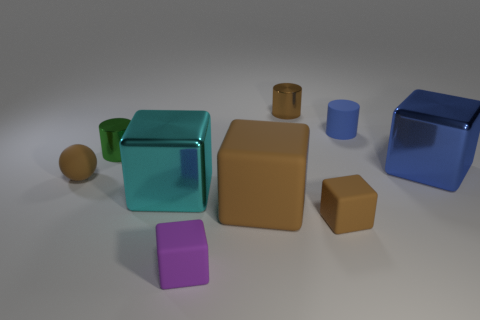Is the color of the sphere the same as the large matte block?
Make the answer very short. Yes. There is a thing that is both in front of the blue metallic block and right of the big brown matte thing; what is its size?
Provide a succinct answer. Small. The blue matte thing has what shape?
Give a very brief answer. Cylinder. How many objects are tiny gray cylinders or metal cylinders behind the tiny green metallic cylinder?
Ensure brevity in your answer.  1. Does the large shiny cube that is right of the purple block have the same color as the matte cylinder?
Ensure brevity in your answer.  Yes. There is a tiny cylinder that is both on the right side of the large brown object and in front of the tiny brown cylinder; what color is it?
Make the answer very short. Blue. There is a block that is left of the tiny purple object; what is it made of?
Your answer should be very brief. Metal. The matte sphere is what size?
Give a very brief answer. Small. How many red objects are cylinders or tiny rubber blocks?
Your response must be concise. 0. What size is the brown object that is behind the brown matte object that is behind the large cyan thing?
Keep it short and to the point. Small. 